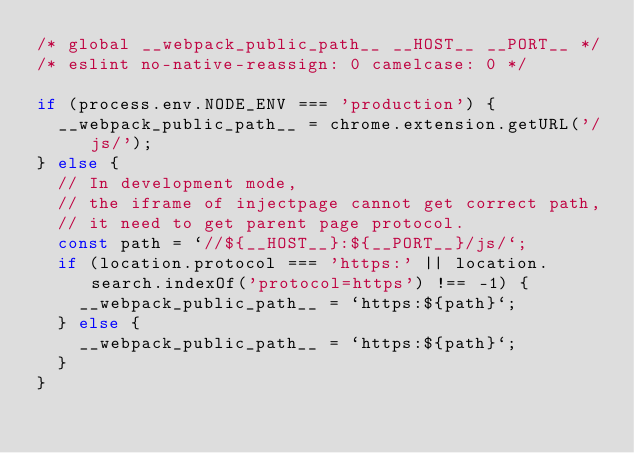<code> <loc_0><loc_0><loc_500><loc_500><_JavaScript_>/* global __webpack_public_path__ __HOST__ __PORT__ */
/* eslint no-native-reassign: 0 camelcase: 0 */

if (process.env.NODE_ENV === 'production') {
  __webpack_public_path__ = chrome.extension.getURL('/js/');
} else {
  // In development mode,
  // the iframe of injectpage cannot get correct path,
  // it need to get parent page protocol.
  const path = `//${__HOST__}:${__PORT__}/js/`;
  if (location.protocol === 'https:' || location.search.indexOf('protocol=https') !== -1) {
    __webpack_public_path__ = `https:${path}`;
  } else {
    __webpack_public_path__ = `https:${path}`;
  }
}
</code> 